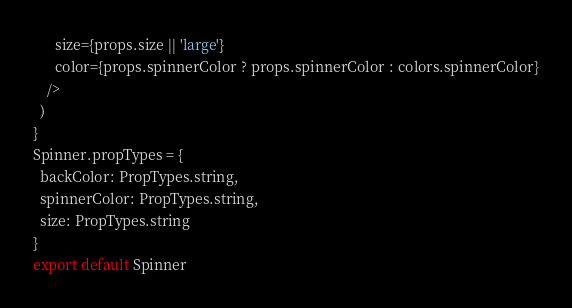<code> <loc_0><loc_0><loc_500><loc_500><_JavaScript_>      size={props.size || 'large'}
      color={props.spinnerColor ? props.spinnerColor : colors.spinnerColor}
    />
  )
}
Spinner.propTypes = {
  backColor: PropTypes.string,
  spinnerColor: PropTypes.string,
  size: PropTypes.string
}
export default Spinner
</code> 